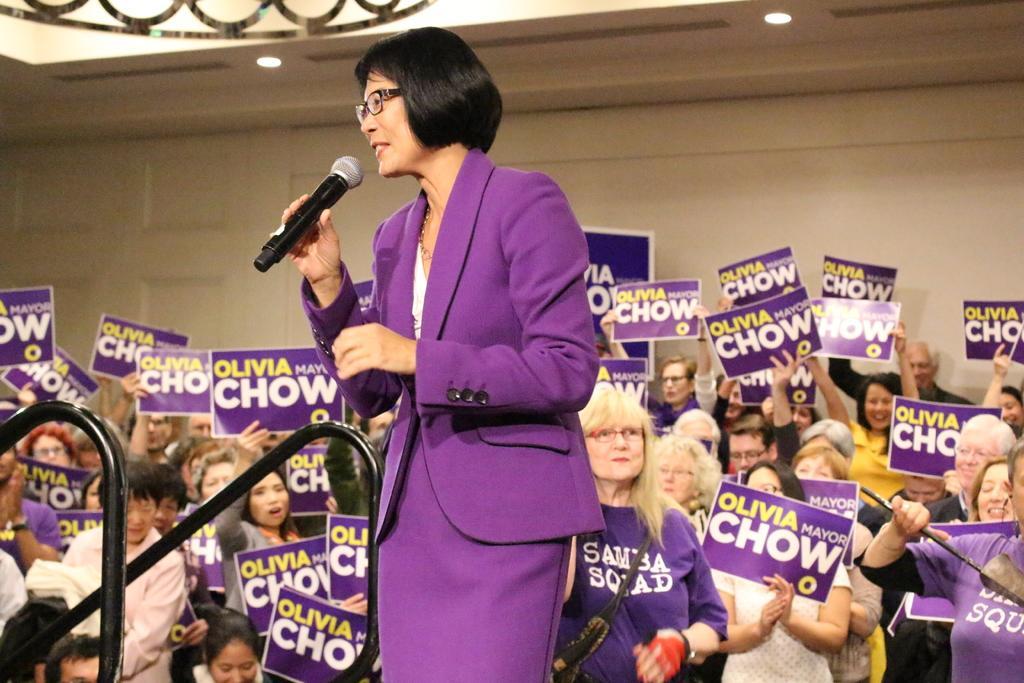In one or two sentences, can you explain what this image depicts? The picture consists of so many people standing and holding placards in their hands and in the center of the picture one woman is standing in a purple dress and holding a microphone and behind the people there is a big wall. 